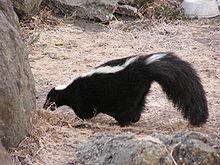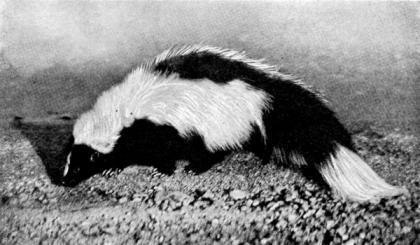The first image is the image on the left, the second image is the image on the right. Considering the images on both sides, is "In the image to the left, the skunk is standing among some green grass." valid? Answer yes or no. No. The first image is the image on the left, the second image is the image on the right. Analyze the images presented: Is the assertion "All skunks are standing with their bodies in profile and all skunks have their bodies turned in the same direction." valid? Answer yes or no. Yes. 